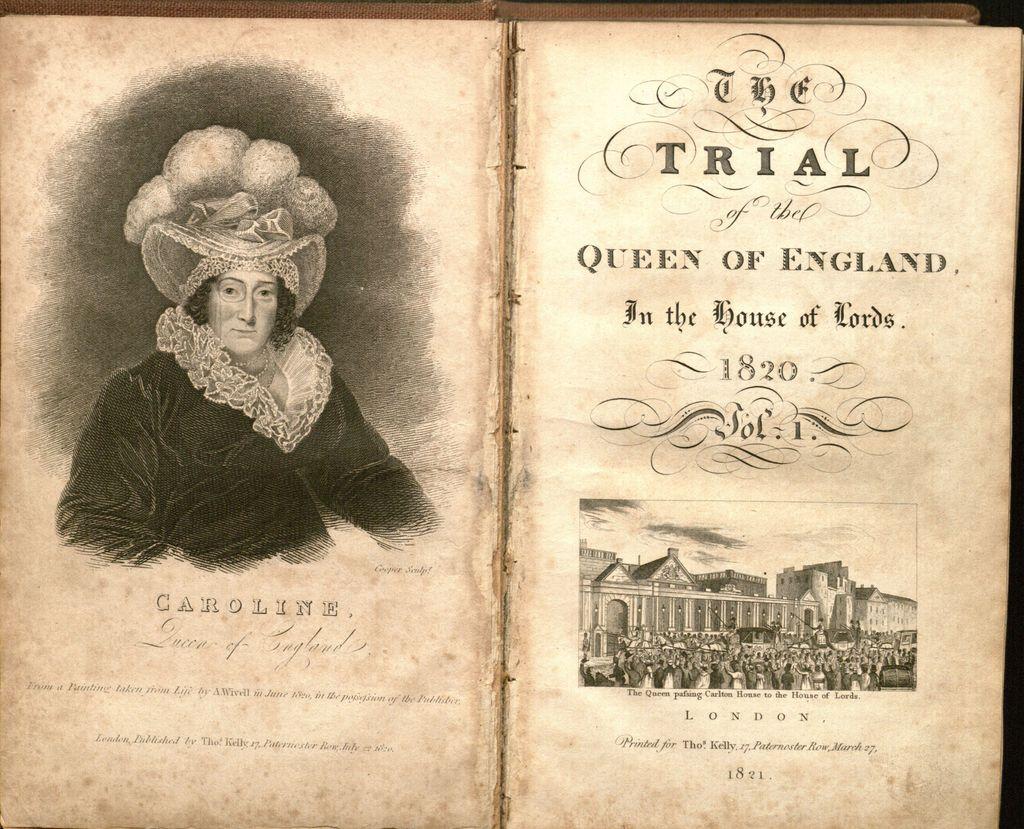In what year did the queen's trial take place?
Offer a very short reply. 1820. What is the lady of the left's name?
Make the answer very short. Caroline. 